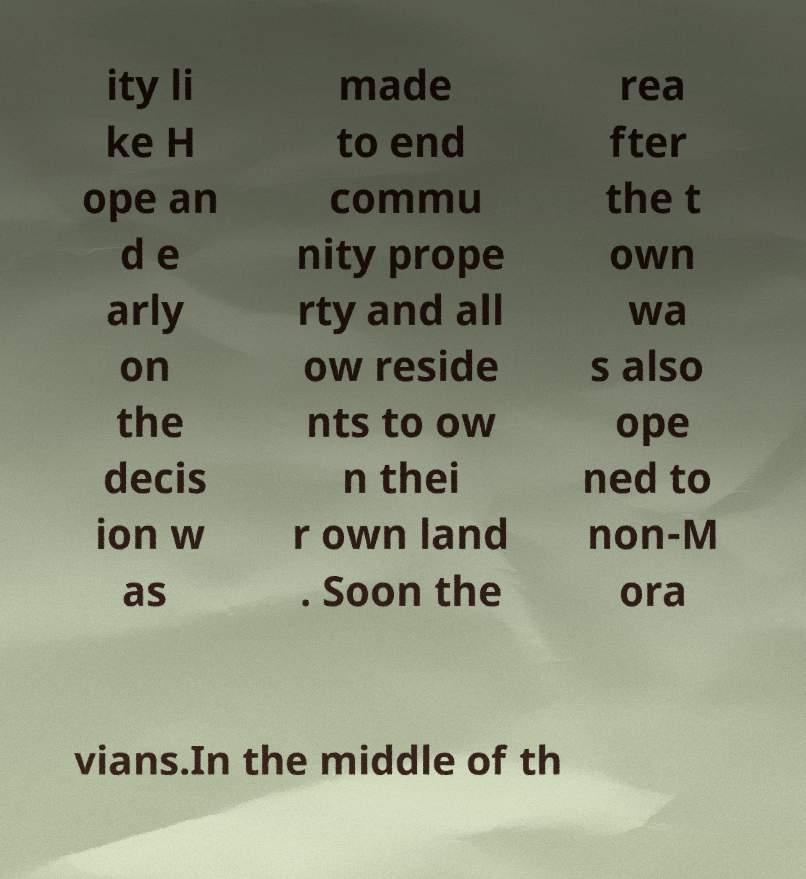Can you accurately transcribe the text from the provided image for me? ity li ke H ope an d e arly on the decis ion w as made to end commu nity prope rty and all ow reside nts to ow n thei r own land . Soon the rea fter the t own wa s also ope ned to non-M ora vians.In the middle of th 